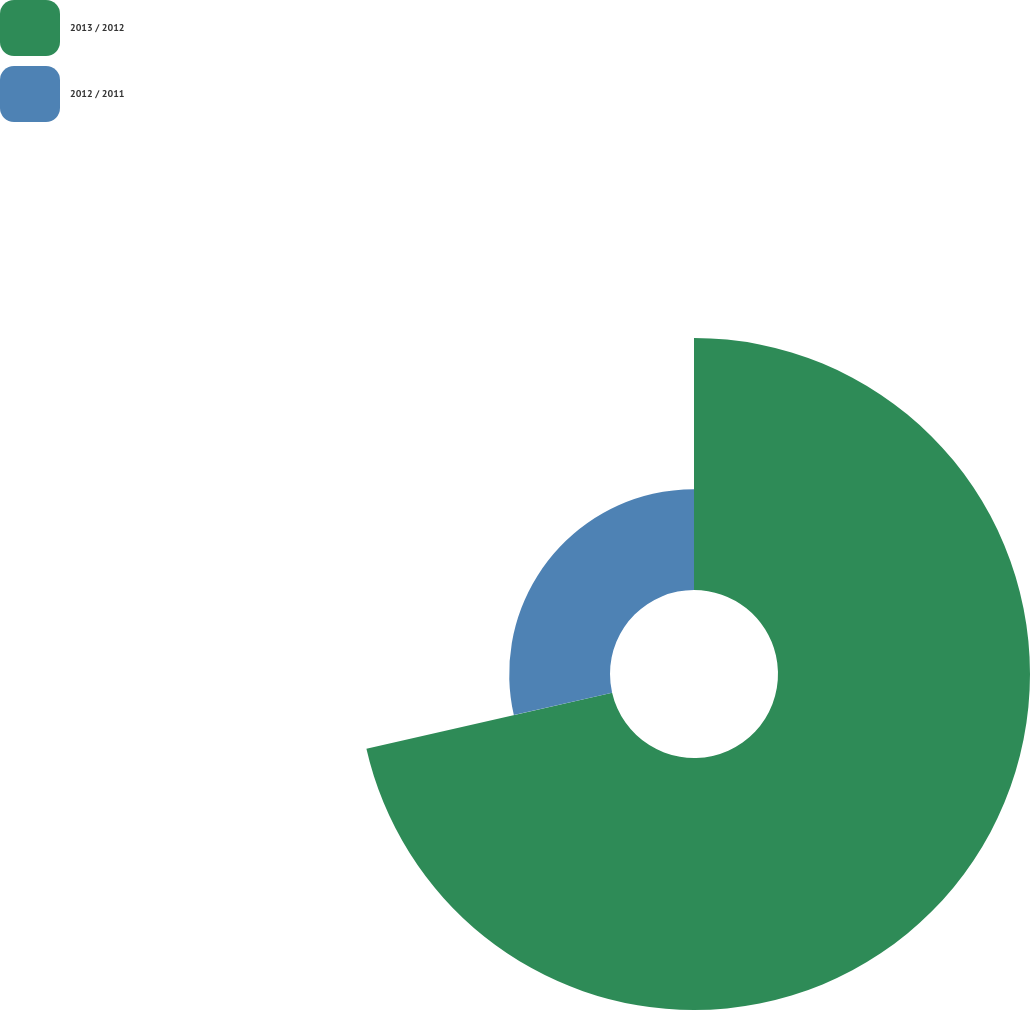<chart> <loc_0><loc_0><loc_500><loc_500><pie_chart><fcel>2013 / 2012<fcel>2012 / 2011<nl><fcel>71.43%<fcel>28.57%<nl></chart> 